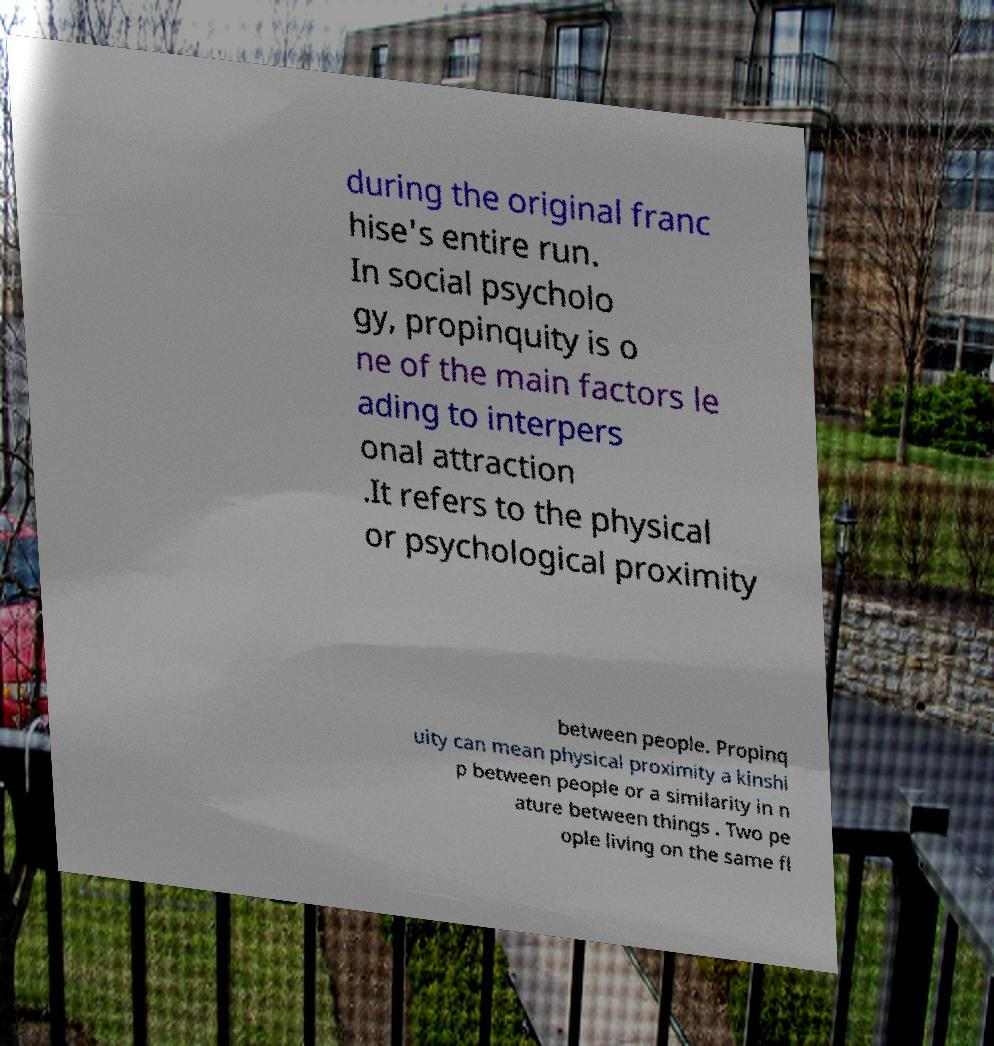For documentation purposes, I need the text within this image transcribed. Could you provide that? during the original franc hise's entire run. In social psycholo gy, propinquity is o ne of the main factors le ading to interpers onal attraction .It refers to the physical or psychological proximity between people. Propinq uity can mean physical proximity a kinshi p between people or a similarity in n ature between things . Two pe ople living on the same fl 